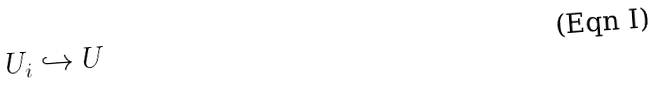<formula> <loc_0><loc_0><loc_500><loc_500>U _ { i } \hookrightarrow U</formula> 